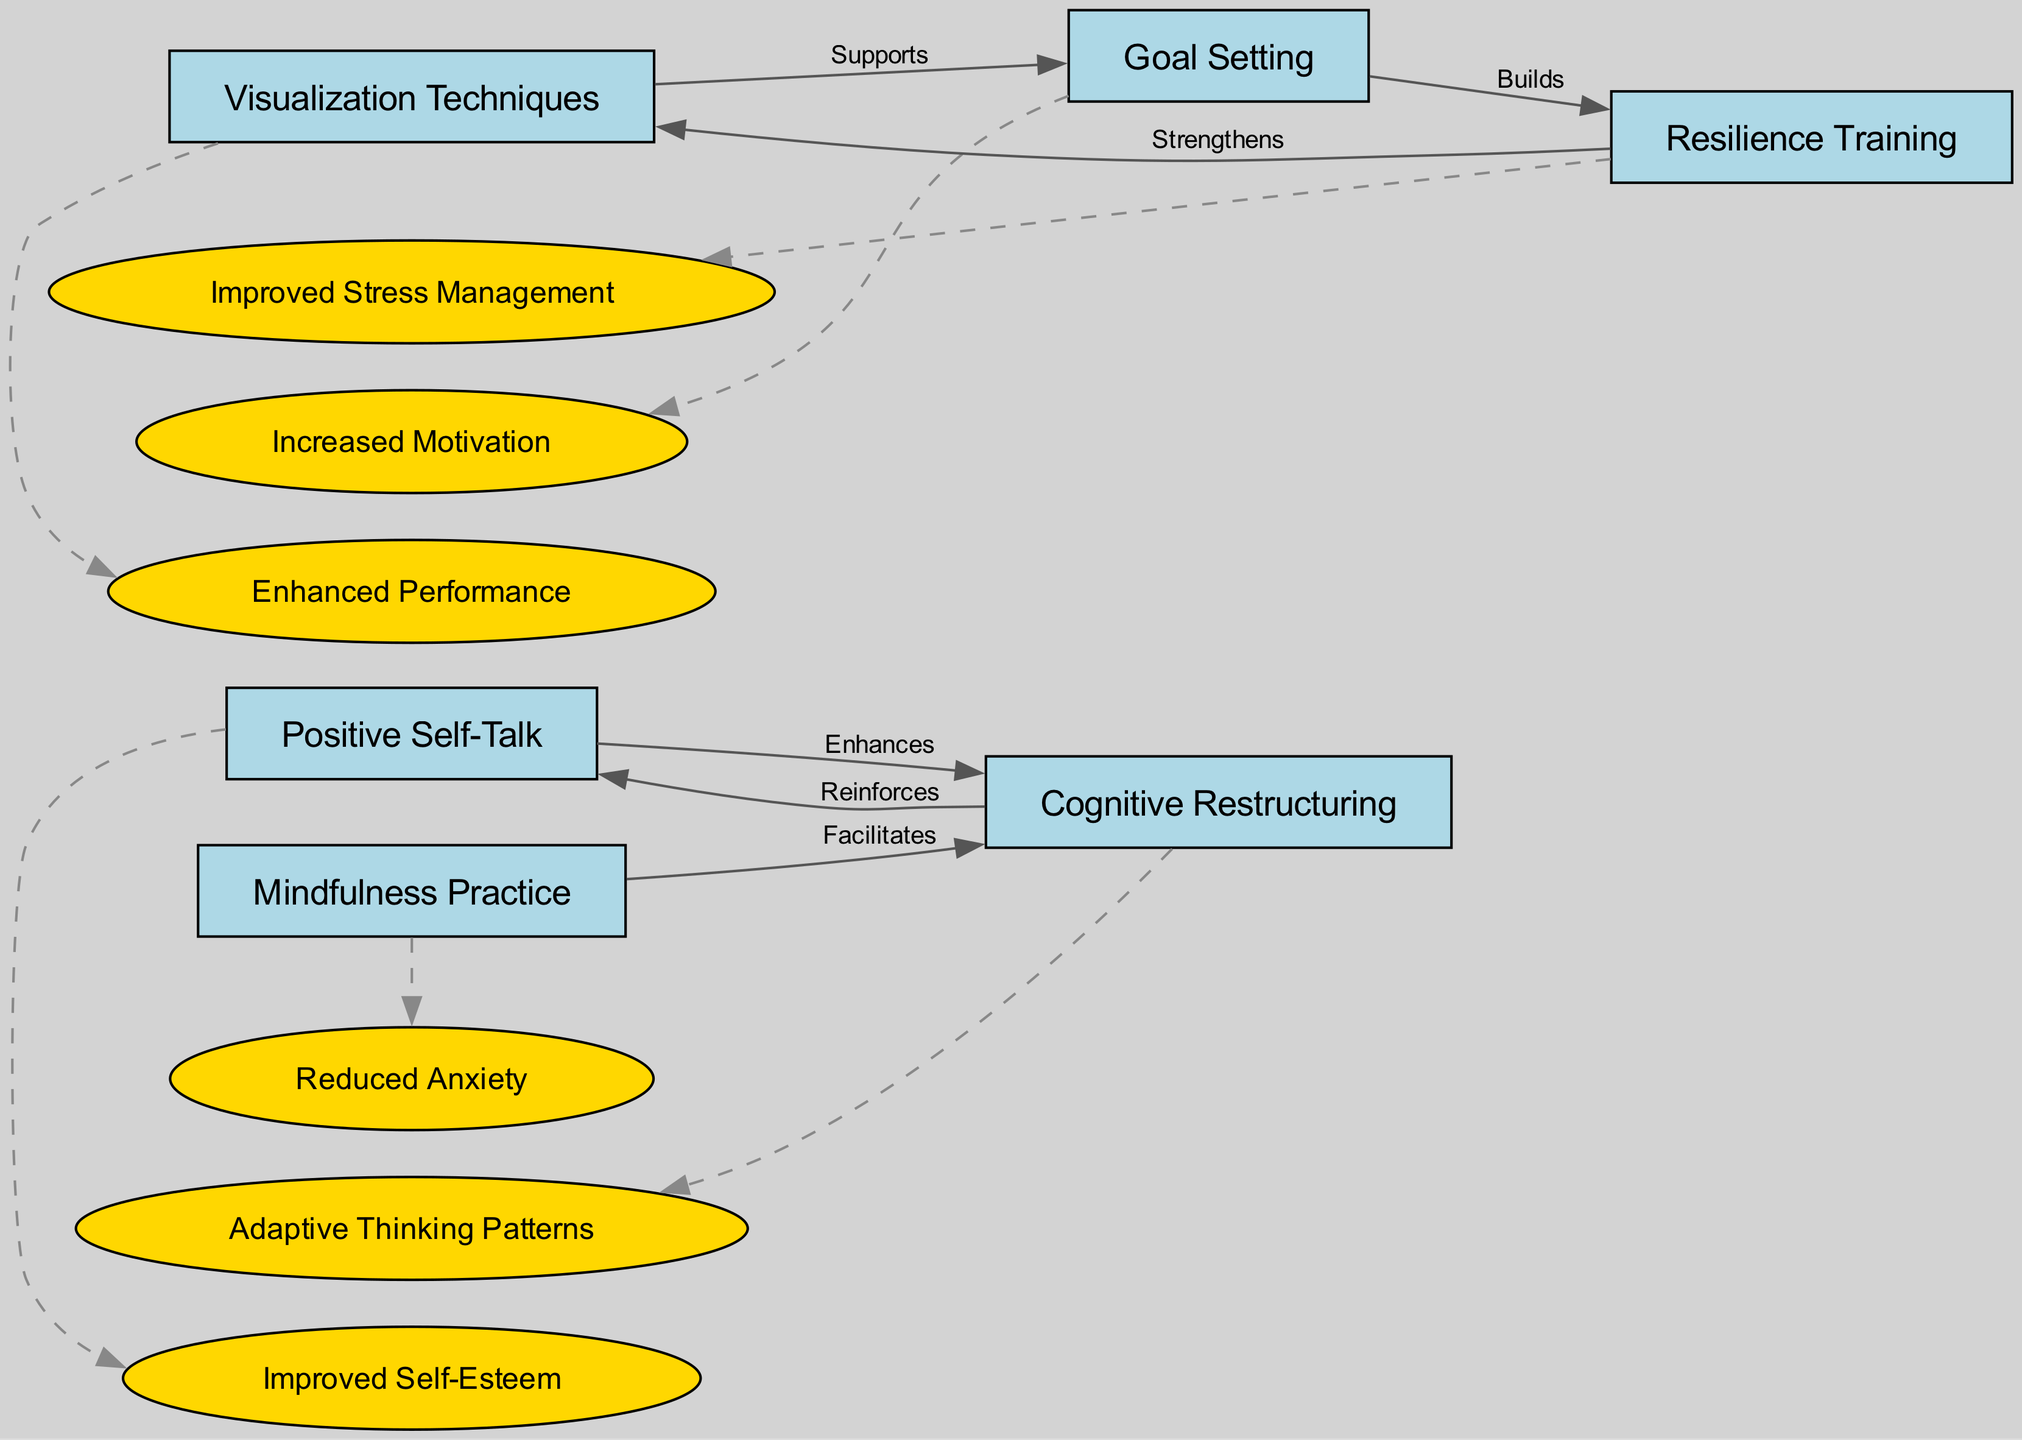What is the total number of nodes in the diagram? The diagram lists six distinct strategies as nodes: Positive Self-Talk, Visualization Techniques, Goal Setting, Mindfulness Practice, Cognitive Restructuring, and Resilience Training. By counting these, we find there are a total of six nodes.
Answer: 6 Which strategy is enhanced by Positive Self-Talk? In the diagram, there is a directed edge labeled "Enhances" connecting Positive Self-Talk to Cognitive Restructuring. This indicates that Cognitive Restructuring is the strategy that is enhanced by Positive Self-Talk.
Answer: Cognitive Restructuring What impact is associated with Resilience Training? The impact linked to Resilience Training in the diagram, as per the list of impacts, is "Improved Stress Management." By identifying the resilience node and looking at its corresponding impact, we can directly answer this.
Answer: Improved Stress Management How many edges connect the various strategies? By reviewing the edges displayed in the diagram, we can see that there are six connections between different strategies, representing the relationships between them. Therefore, the total number of edges is six.
Answer: 6 What does Goal Setting build according to the diagram? The diagram shows an edge labeled "Builds" pointing from Goal Setting to Resilience Training. This means that Goal Setting is responsible for building Resilience Training.
Answer: Resilience Training Which strategy's effectiveness is strengthened by Resilience Training? According to the diagram, there is a connection labeled "Strengthens" that leads from Resilience Training to Visualization Techniques. This indicates that the effectiveness of Visualization Techniques is strengthened by Resilience Training.
Answer: Visualization Techniques What type of thinking patterns does Cognitive Restructuring promote? From the impacts section linked to Cognitive Restructuring in the diagram, the impact listed is "Adaptive Thinking Patterns," which directly describes the type of thinking patterns promoted by this strategy.
Answer: Adaptive Thinking Patterns What psychological effect is facilitated by Mindfulness Practice? The diagram connects Mindfulness Practice with Cognitive Restructuring using an edge labeled "Facilitates." Additionally, the impact associated with Cognitive Restructuring is "Adaptive Thinking Patterns," indicating that Mindfulness Practice plays a role in facilitating this effect.
Answer: Adaptive Thinking Patterns 